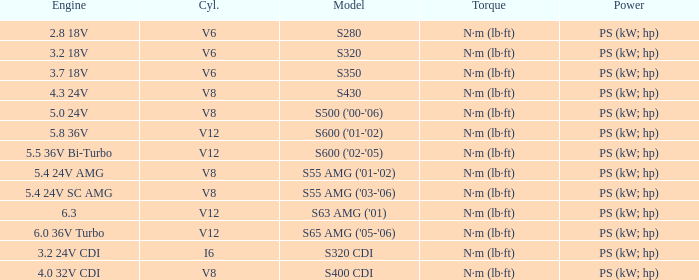Which Engine has a Model of s430? 4.3 24V. 